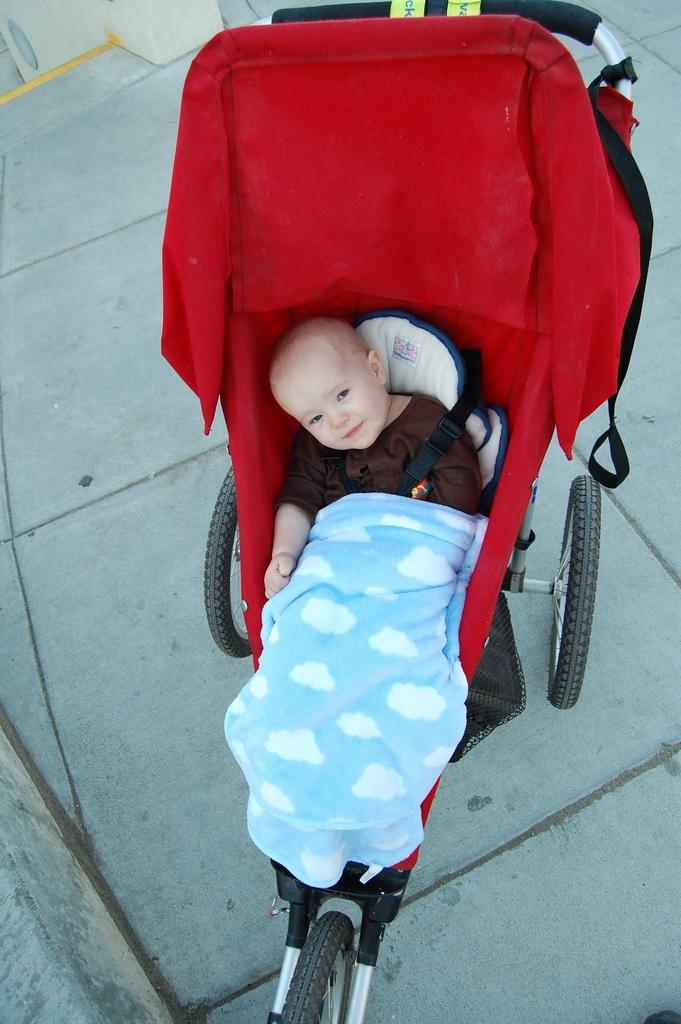What is the main subject of the image? There is a baby in the image. Where is the baby located? The baby is sitting in a vehicle. What is visible at the bottom of the image? There is a walkway at the bottom of the image. What can be seen in the background of the image? There is a wall in the background of the image. How many pieces of quartz can be seen on the baby's lap in the image? There is no quartz present in the image, so it is not possible to determine the number of pieces on the baby's lap. 